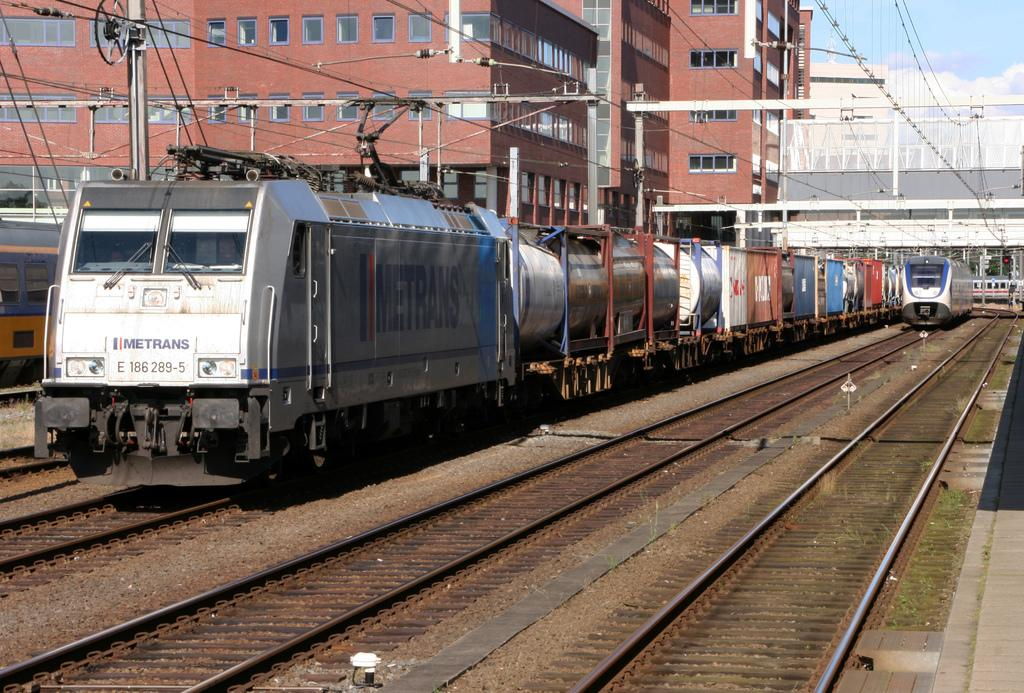Provide a one-sentence caption for the provided image. A Metrans train traces along a set of tracks in the city. 